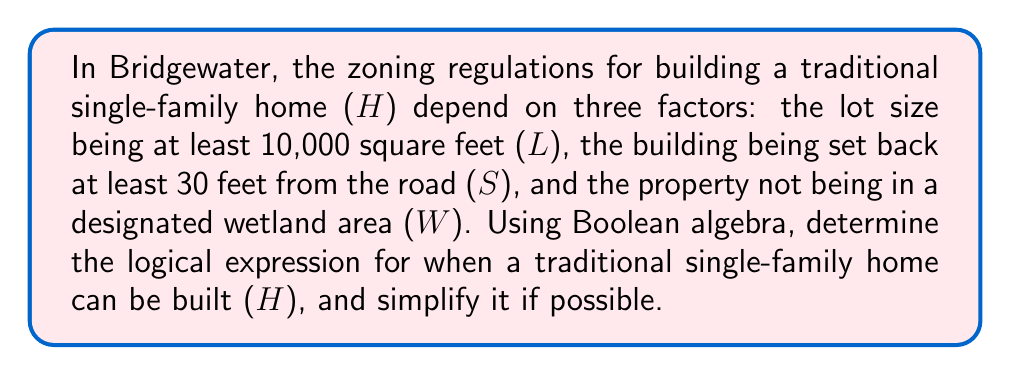Provide a solution to this math problem. Let's approach this step-by-step using Boolean algebra:

1) First, we define our variables:
   H: A traditional single-family home can be built
   L: The lot size is at least 10,000 square feet
   S: The building is set back at least 30 feet from the road
   W: The property is not in a designated wetland area

2) The logical expression for when a home can be built is:
   $$ H = L \land S \land W $$
   
   This means a home can be built if and only if all three conditions are met.

3) In Boolean algebra, this expression is already in its simplest form. The $\land$ (AND) operation requires all inputs to be true for the output to be true.

4) We can represent this using a truth table:

   | L | S | W | H |
   |---|---|---|---|
   | 0 | 0 | 0 | 0 |
   | 0 | 0 | 1 | 0 |
   | 0 | 1 | 0 | 0 |
   | 0 | 1 | 1 | 0 |
   | 1 | 0 | 0 | 0 |
   | 1 | 0 | 1 | 0 |
   | 1 | 1 | 0 | 0 |
   | 1 | 1 | 1 | 1 |

5) As we can see, H is only true (1) when all L, S, and W are true (1).

6) This logical expression aligns with traditional zoning practices, ensuring proper lot sizes, setbacks, and environmental considerations.
Answer: $$ H = L \land S \land W $$ 